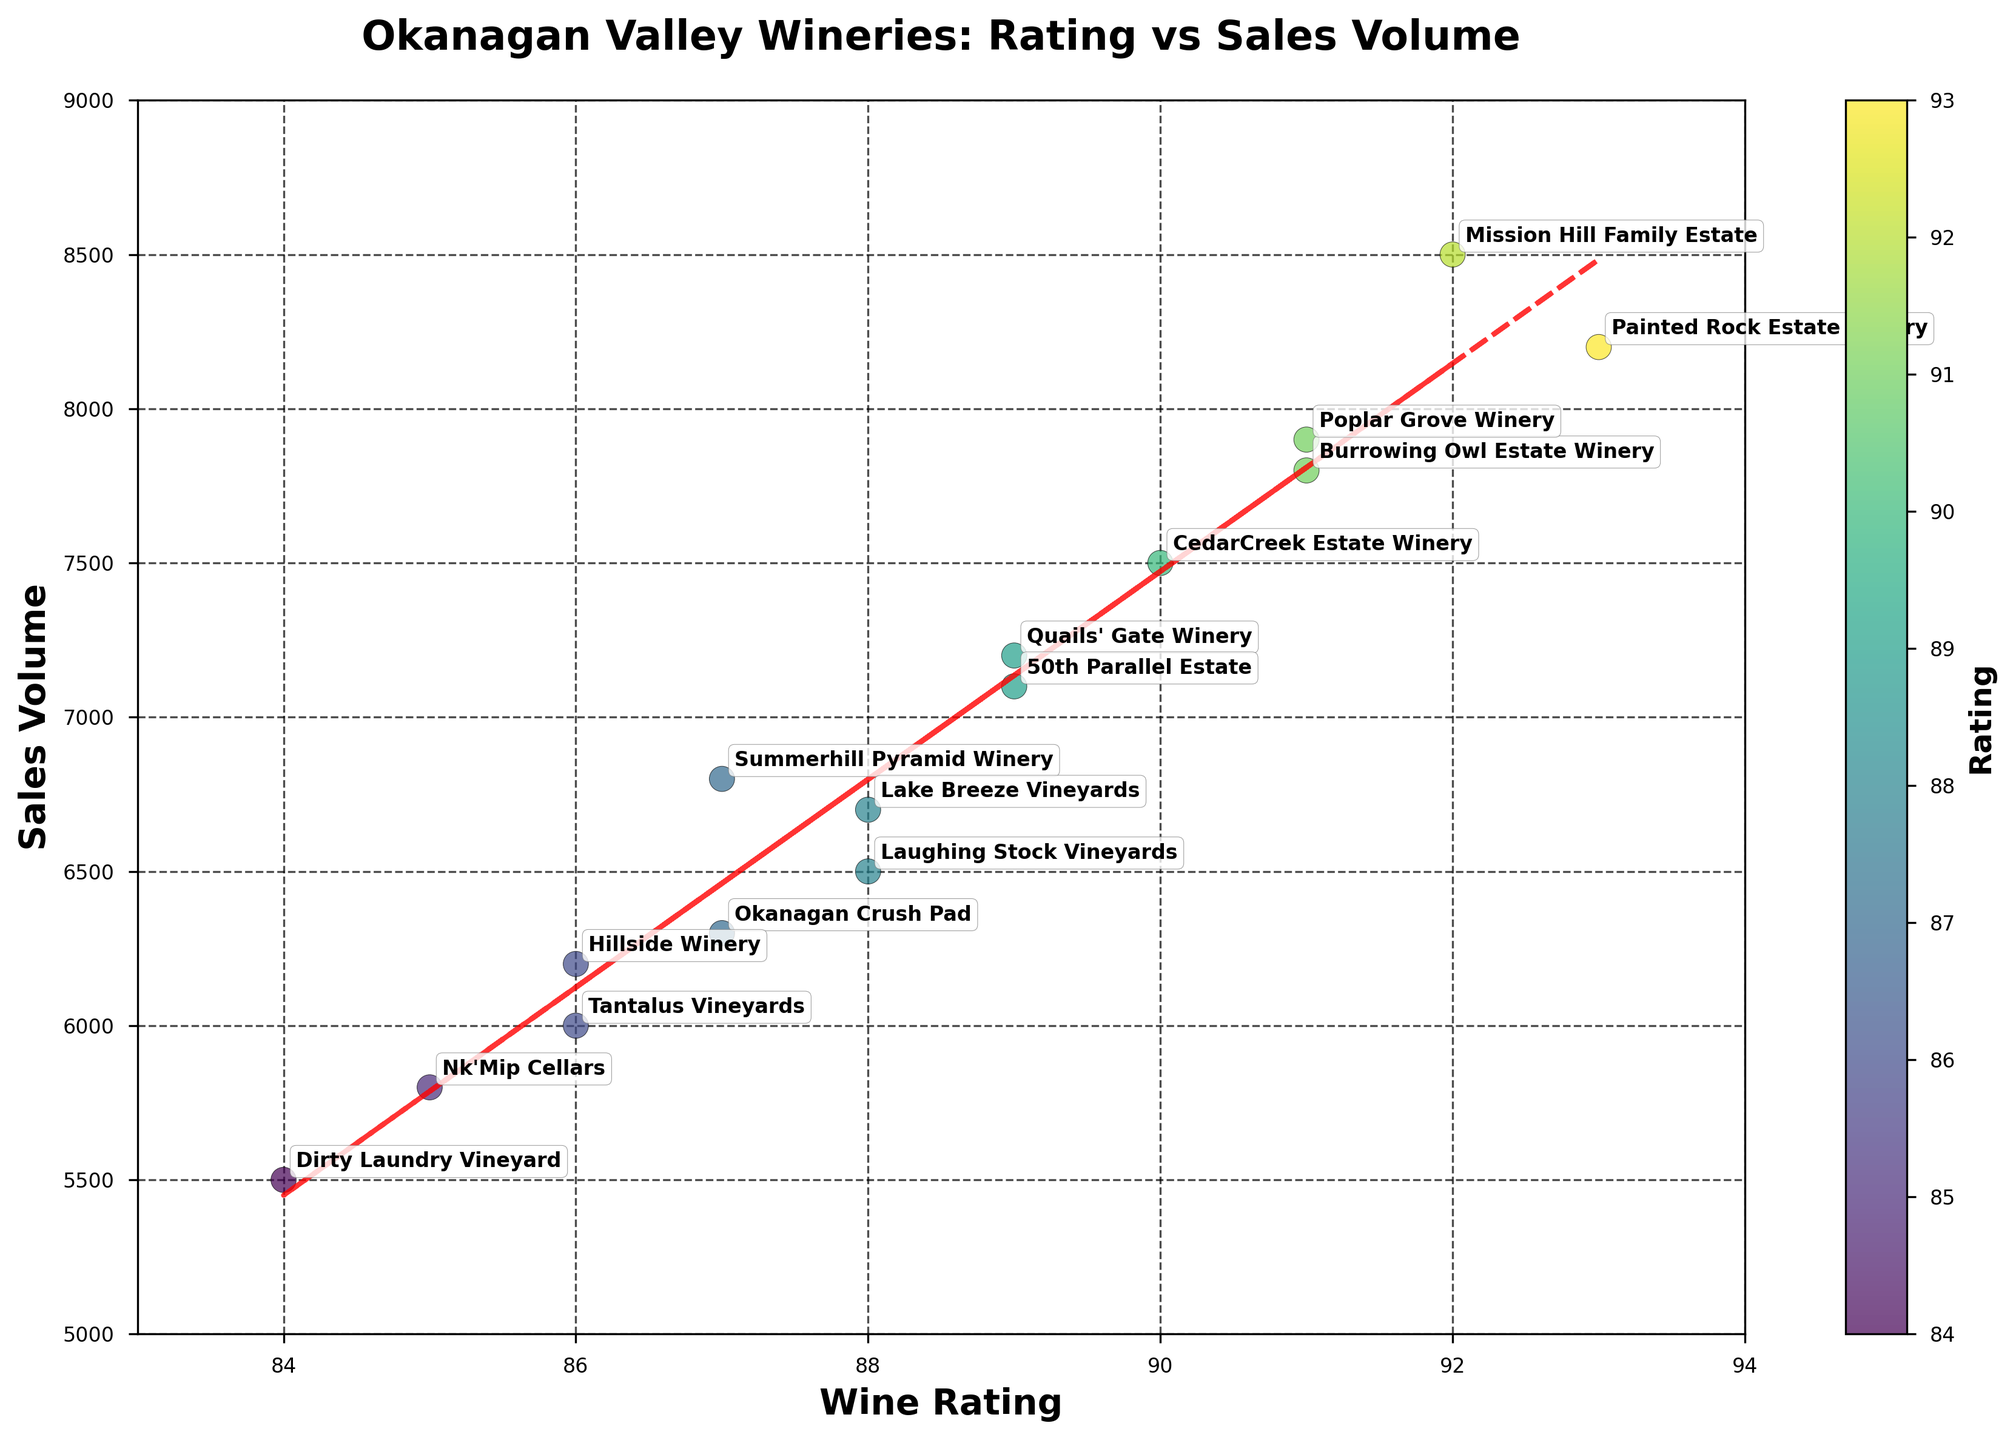What is the highest wine rating among the wineries? The highest wine rating can be identified by looking at the Y-axis and finding the highest point. The highest rating on the Y-axis corresponds to Painted Rock Estate Winery with a rating of 93.
Answer: 93 Which winery has the lowest sales volume? The lowest sales volume can be identified by looking at the X-axis and finding the lowest point. Dirty Laundry Vineyard has the lowest sales volume of 5500.
Answer: Dirty Laundry Vineyard Is there a trend between wine ratings and sales volumes? The trend can be identified by looking at the scatter plot and observing the red dashed trend line that represents a linear fit. The positive slope of the trend line suggests that higher ratings are generally associated with higher sales volumes.
Answer: Yes, there is a positive trend Which wineries have a rating of 89? To find the wineries with a rating of 89, look for the points on the scatter plot that correspond to this rating on the Y-axis. The wineries with a rating of 89 are Quails' Gate Winery and 50th Parallel Estate.
Answer: Quails' Gate Winery, 50th Parallel Estate How does the sales volume of Mission Hill Family Estate compare to other wineries? Mission Hill Family Estate has a sales volume of 8500, which is one of the highest sales volumes among the wineries plotted on the scatter plot. Only Painted Rock Estate Winery has a similar volume.
Answer: One of the highest How many wineries have a rating above 90? To determine the number of wineries with a rating above 90, count the data points (wineries) that are above the 90 mark on the Y-axis. The wineries with ratings above 90 are Mission Hill Family Estate, Burrowing Owl Estate Winery, Painted Rock Estate Winery, and Poplar Grove Winery, making a total of 4.
Answer: 4 What does the color of the points represent in the figure? The color of the points represents the wine rating according to the colorbar. Wineries with higher ratings have colors closer to yellow, and those with lower ratings are closer to purple.
Answer: Wine rating Would Tantalus Vineyards be considered a high-selling winery based on its position on the plot? Tantalus Vineyards has a sales volume of 6000, which is on the lower end compared to other wineries in the plot. Thus, it wouldn't be considered a high-selling winery based on its position on the plot.
Answer: No What is the approximate correlation between the wine ratings and sales volumes, based on the trend line? The correlation can be approximated based on the trend line's slope. Since the trend line has a positive slope, it suggests a positive correlation between wine ratings and sales volumes, indicating that as the rating increases, sales volume generally increases as well.
Answer: Positive correlation 